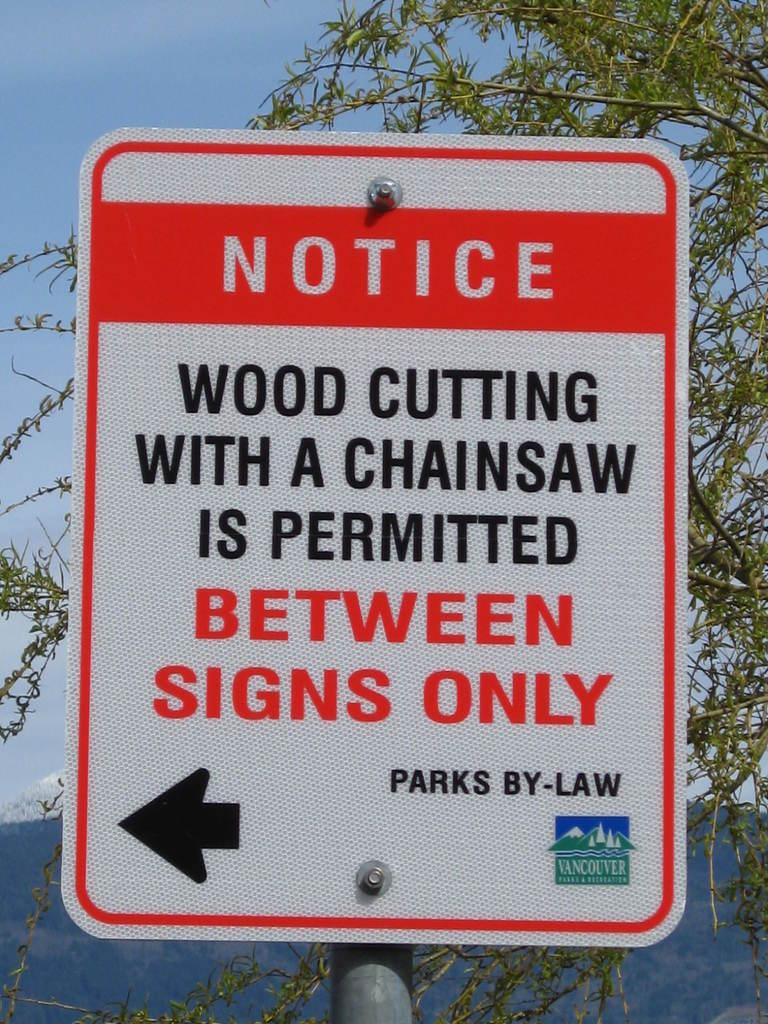What does the sign say?
Offer a terse response. Notice wood cutting with a chainsaw is permitted between signs only parks by-law. What can you do with a chainsaw?
Provide a succinct answer. Wood cutting. 